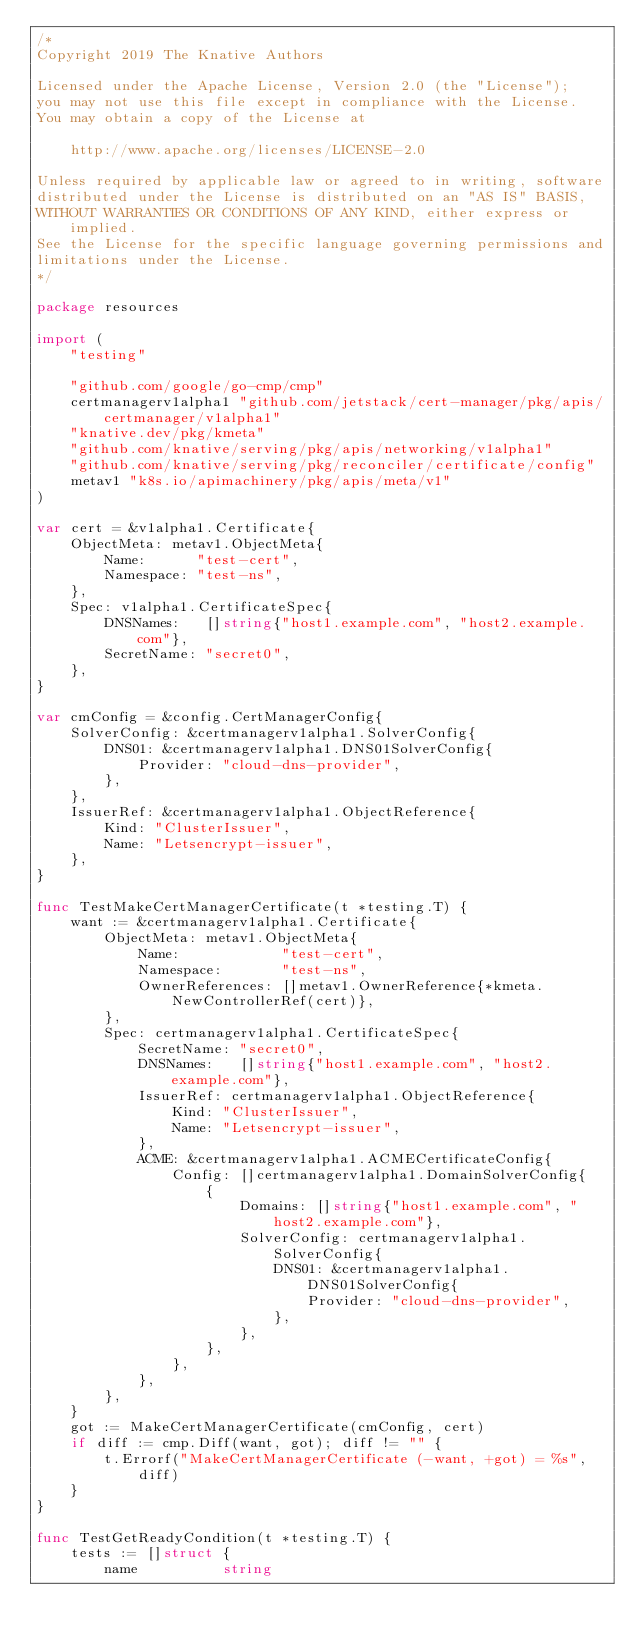Convert code to text. <code><loc_0><loc_0><loc_500><loc_500><_Go_>/*
Copyright 2019 The Knative Authors

Licensed under the Apache License, Version 2.0 (the "License");
you may not use this file except in compliance with the License.
You may obtain a copy of the License at

	http://www.apache.org/licenses/LICENSE-2.0

Unless required by applicable law or agreed to in writing, software
distributed under the License is distributed on an "AS IS" BASIS,
WITHOUT WARRANTIES OR CONDITIONS OF ANY KIND, either express or implied.
See the License for the specific language governing permissions and
limitations under the License.
*/

package resources

import (
	"testing"

	"github.com/google/go-cmp/cmp"
	certmanagerv1alpha1 "github.com/jetstack/cert-manager/pkg/apis/certmanager/v1alpha1"
	"knative.dev/pkg/kmeta"
	"github.com/knative/serving/pkg/apis/networking/v1alpha1"
	"github.com/knative/serving/pkg/reconciler/certificate/config"
	metav1 "k8s.io/apimachinery/pkg/apis/meta/v1"
)

var cert = &v1alpha1.Certificate{
	ObjectMeta: metav1.ObjectMeta{
		Name:      "test-cert",
		Namespace: "test-ns",
	},
	Spec: v1alpha1.CertificateSpec{
		DNSNames:   []string{"host1.example.com", "host2.example.com"},
		SecretName: "secret0",
	},
}

var cmConfig = &config.CertManagerConfig{
	SolverConfig: &certmanagerv1alpha1.SolverConfig{
		DNS01: &certmanagerv1alpha1.DNS01SolverConfig{
			Provider: "cloud-dns-provider",
		},
	},
	IssuerRef: &certmanagerv1alpha1.ObjectReference{
		Kind: "ClusterIssuer",
		Name: "Letsencrypt-issuer",
	},
}

func TestMakeCertManagerCertificate(t *testing.T) {
	want := &certmanagerv1alpha1.Certificate{
		ObjectMeta: metav1.ObjectMeta{
			Name:            "test-cert",
			Namespace:       "test-ns",
			OwnerReferences: []metav1.OwnerReference{*kmeta.NewControllerRef(cert)},
		},
		Spec: certmanagerv1alpha1.CertificateSpec{
			SecretName: "secret0",
			DNSNames:   []string{"host1.example.com", "host2.example.com"},
			IssuerRef: certmanagerv1alpha1.ObjectReference{
				Kind: "ClusterIssuer",
				Name: "Letsencrypt-issuer",
			},
			ACME: &certmanagerv1alpha1.ACMECertificateConfig{
				Config: []certmanagerv1alpha1.DomainSolverConfig{
					{
						Domains: []string{"host1.example.com", "host2.example.com"},
						SolverConfig: certmanagerv1alpha1.SolverConfig{
							DNS01: &certmanagerv1alpha1.DNS01SolverConfig{
								Provider: "cloud-dns-provider",
							},
						},
					},
				},
			},
		},
	}
	got := MakeCertManagerCertificate(cmConfig, cert)
	if diff := cmp.Diff(want, got); diff != "" {
		t.Errorf("MakeCertManagerCertificate (-want, +got) = %s", diff)
	}
}

func TestGetReadyCondition(t *testing.T) {
	tests := []struct {
		name          string</code> 